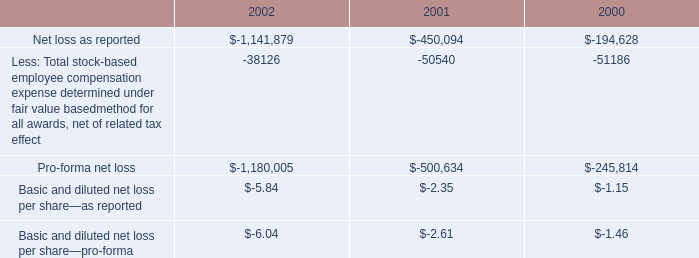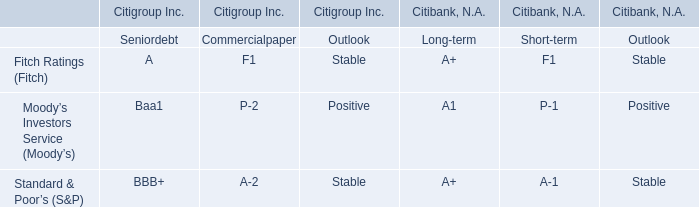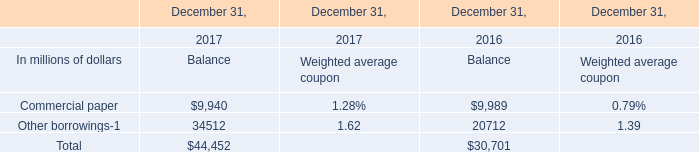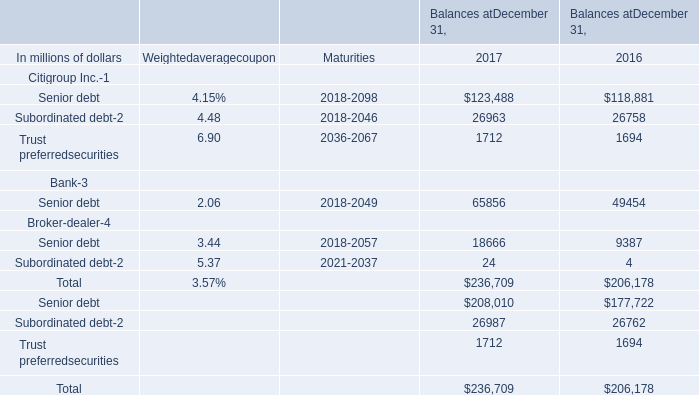If Other borrowings for Balance develops with the same increasing rate in 2017, what will it reach in 2018? (in million) 
Computations: (34512 * (1 + ((34512 - 20712) / 20712)))
Answer: 57506.66976. 